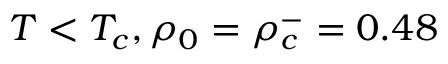Convert formula to latex. <formula><loc_0><loc_0><loc_500><loc_500>T < T _ { c } , \rho _ { 0 } = \rho _ { c } ^ { - } = 0 . 4 8</formula> 